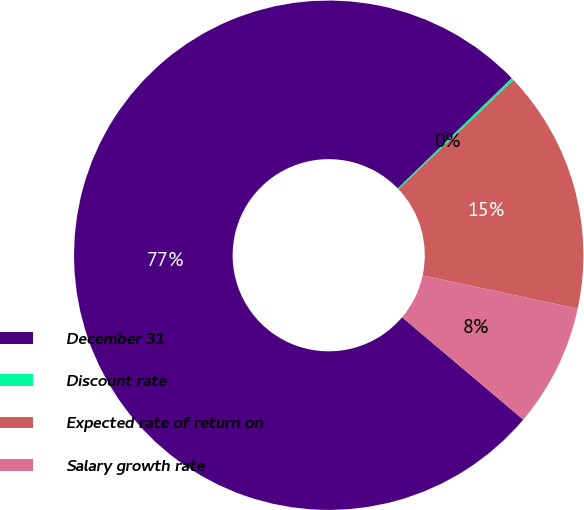<chart> <loc_0><loc_0><loc_500><loc_500><pie_chart><fcel>December 31<fcel>Discount rate<fcel>Expected rate of return on<fcel>Salary growth rate<nl><fcel>76.6%<fcel>0.16%<fcel>15.44%<fcel>7.8%<nl></chart> 